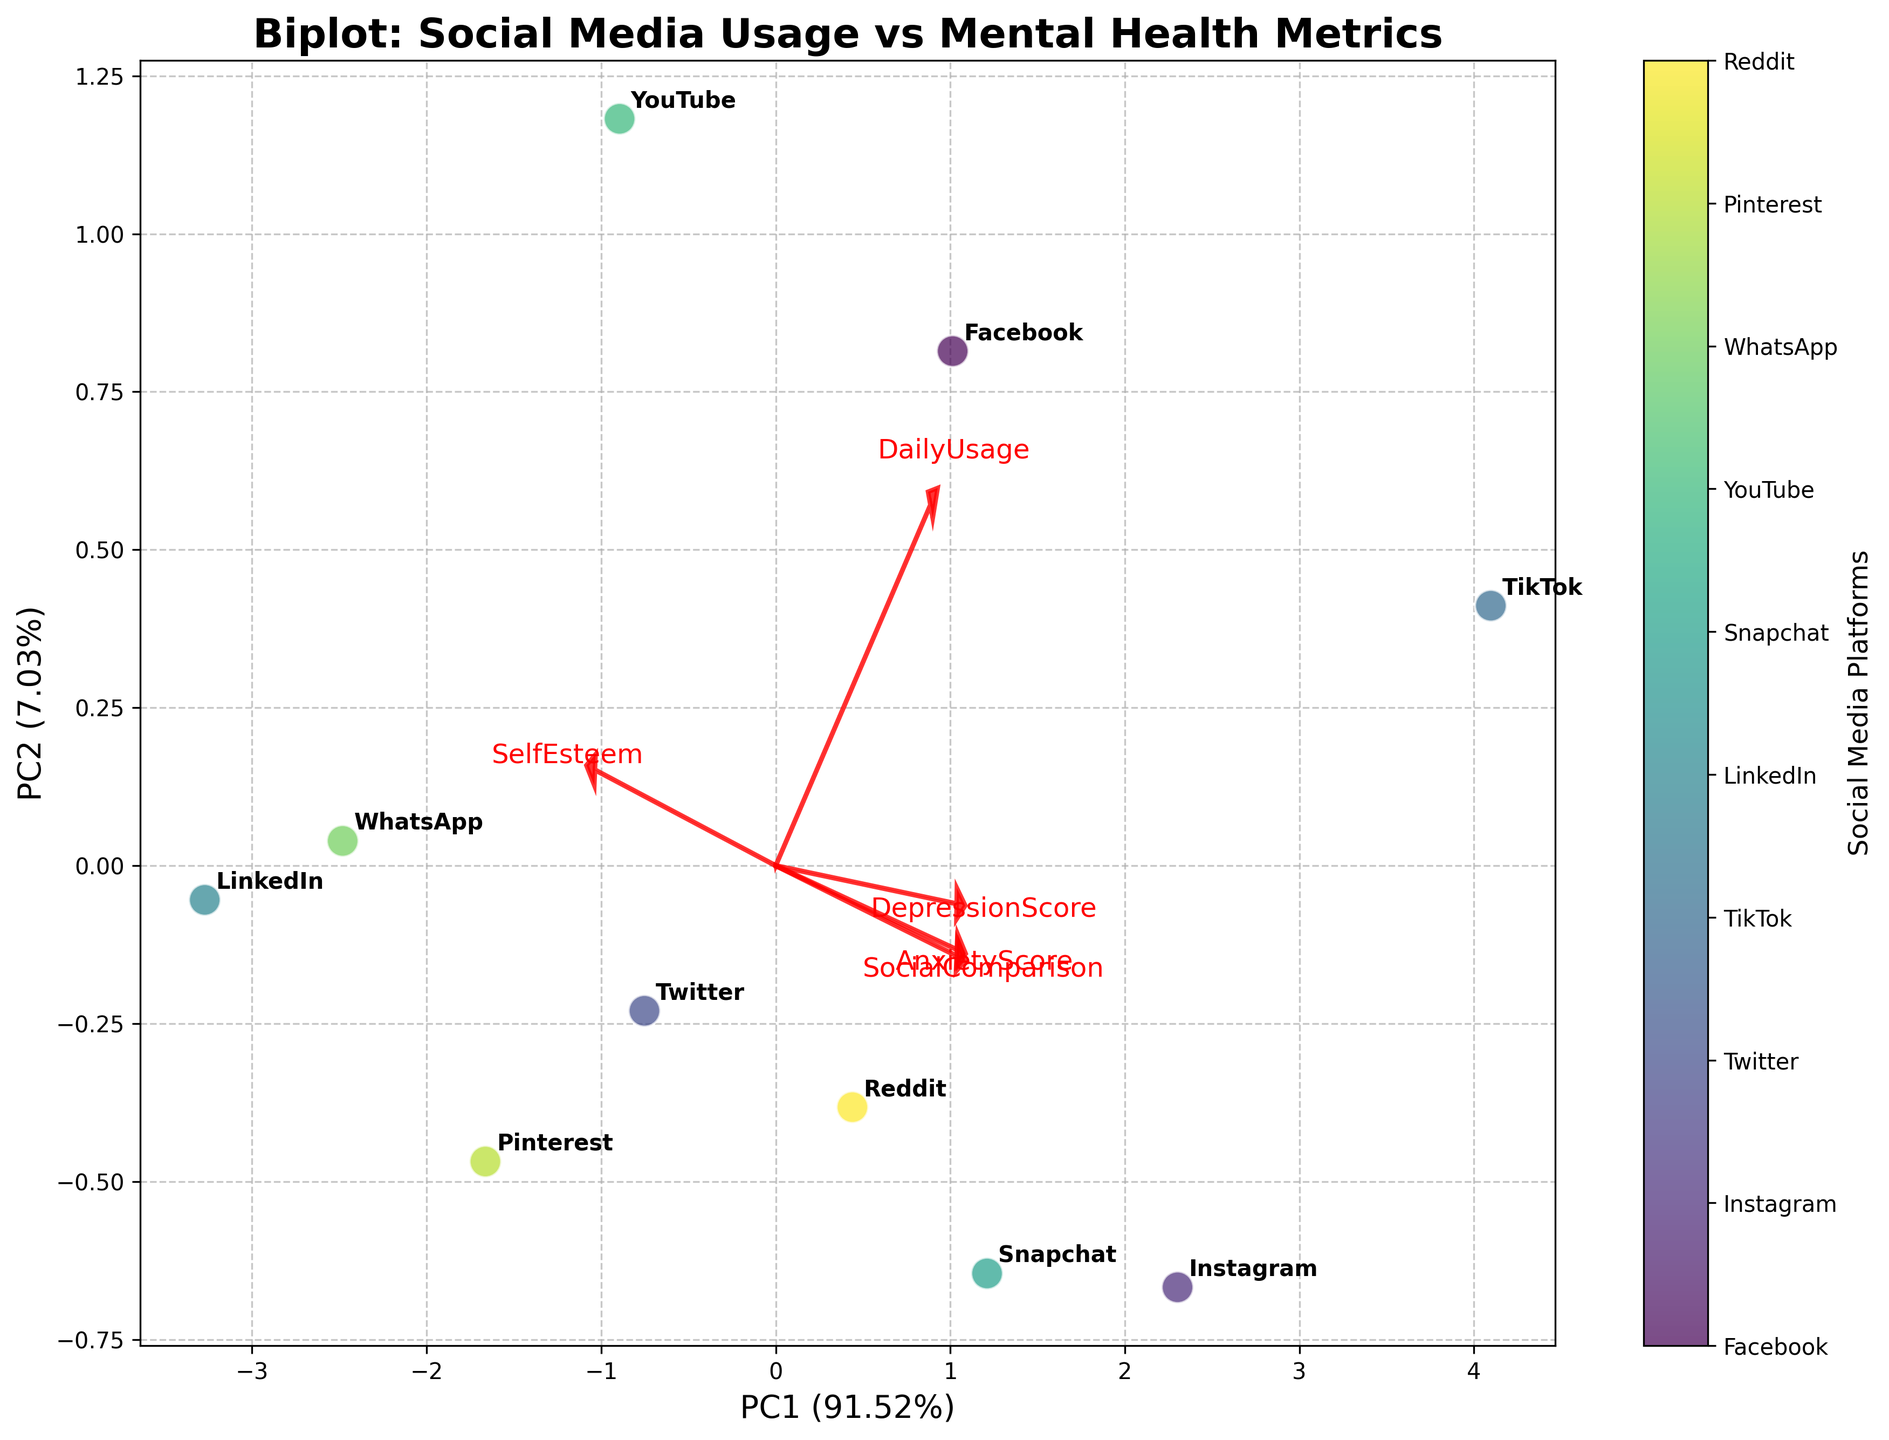How many social media platforms are represented in the figure? Count the number of different labels corresponding to social media platforms in the biplot. The scatter points are annotated with platform names.
Answer: 10 Which social media platform shows the highest daily usage? Find the platform label that is furthest along the direction where "DailyUsage" vector points. This indicates high values of daily usage.
Answer: TikTok What percentage of the variance is explained by the first principal component? Look at the label of the X-axis, which shows the percentage of variance explained by the first principal component (PC1).
Answer: 53.46% Which mental health metric has the strongest correlation with PC1? Identify the loading vector of PC1 that has the longest arrow among all vectors representing mental health metrics. This represents the strongest correlation with PC1.
Answer: AnxietyScore Between Facebook and LinkedIn, which has a higher AnxietyScore? Find the annotations for Facebook and LinkedIn on the scatter plot and observe their position along the direction of the "AnxietyScore" loading vector. The closer one to the arrow tip has a higher AnxietyScore.
Answer: Facebook Is the "DepressionScore" vector pointing towards similar directions as "AnxietyScore"? Compare the direction of the arrows for "DepressionScore" and "AnxietyScore" vectors. If they point mostly in the same direction, their correlation is positive.
Answer: Yes Which metric does Instagram have a notably low value in, compared to LinkedIn? Identify the annotations for Instagram and LinkedIn, compare their distances in the direction opposite to the vector representing a metric, indicating a notably lower value for Instagram.
Answer: SelfEsteem Which platform shows the lowest social comparison value? Look for the platform annotation closest to the origin along the direction that indicates low SocialComparison scores.
Answer: LinkedIn How do YouTube and Snapchat compare in terms of SelfEsteem? Compare the distances from the origin of the scatter points labeled "YouTube" and "Snapchat" in the direction of the "SelfEsteem" loading vector. The further out, the higher the SelfEsteem.
Answer: YouTube Is there a noticeable correlation between daily usage and reported mental health issues? Evaluate the directions and lengths of the loading vectors for daily usage and each mental health metric. If vectors for daily usage and any mental health metric are pointing in a similar direction, there's a noticeable correlation.
Answer: Yes 